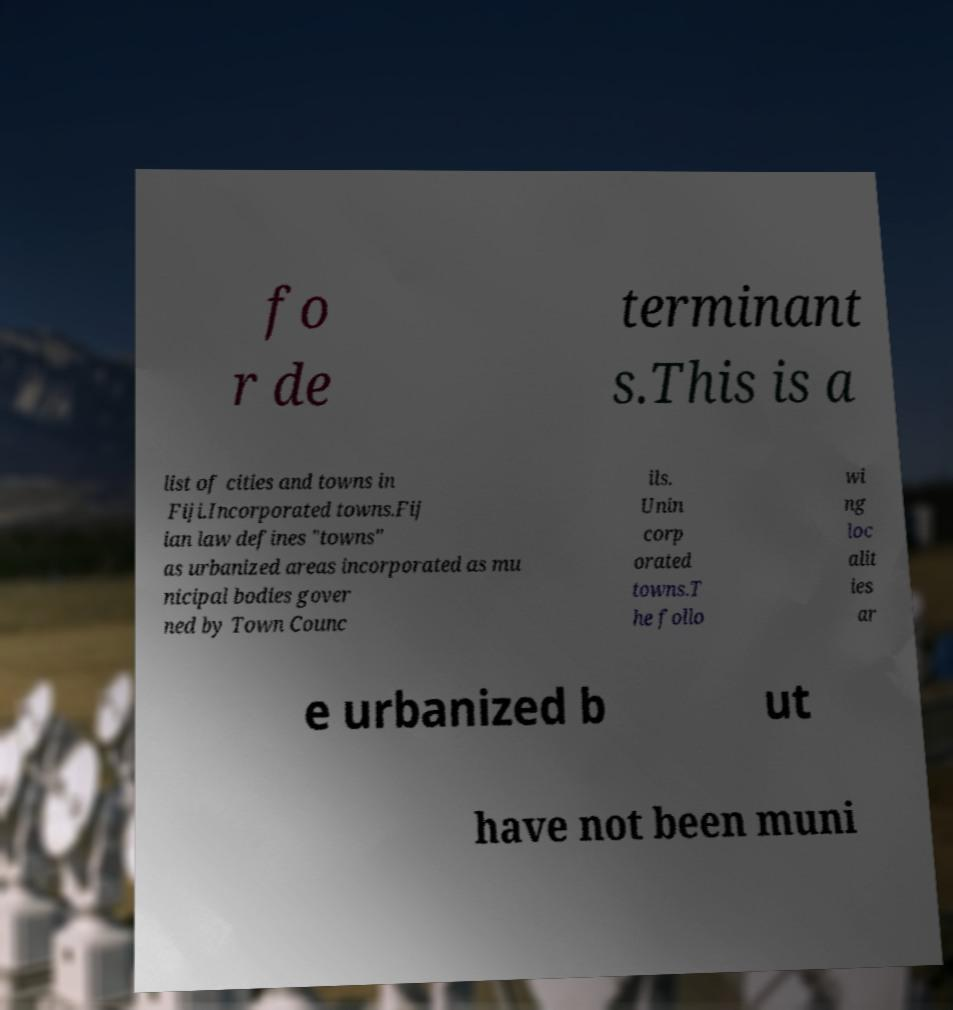Please identify and transcribe the text found in this image. fo r de terminant s.This is a list of cities and towns in Fiji.Incorporated towns.Fij ian law defines "towns" as urbanized areas incorporated as mu nicipal bodies gover ned by Town Counc ils. Unin corp orated towns.T he follo wi ng loc alit ies ar e urbanized b ut have not been muni 